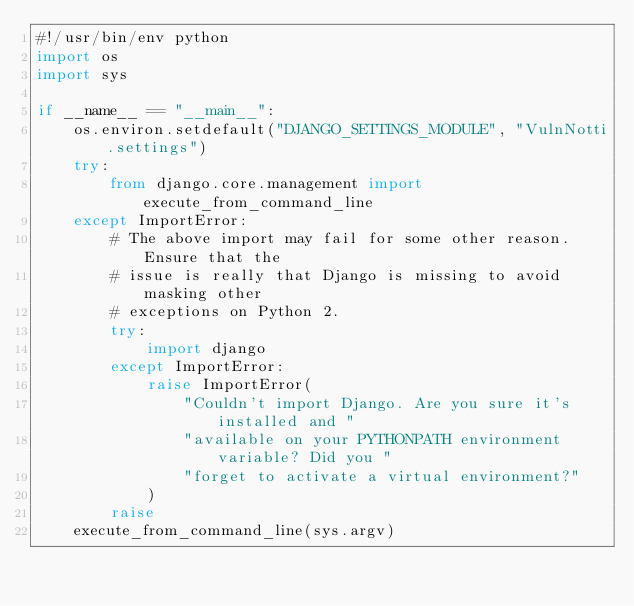<code> <loc_0><loc_0><loc_500><loc_500><_Python_>#!/usr/bin/env python
import os
import sys

if __name__ == "__main__":
    os.environ.setdefault("DJANGO_SETTINGS_MODULE", "VulnNotti.settings")
    try:
        from django.core.management import execute_from_command_line
    except ImportError:
        # The above import may fail for some other reason. Ensure that the
        # issue is really that Django is missing to avoid masking other
        # exceptions on Python 2.
        try:
            import django
        except ImportError:
            raise ImportError(
                "Couldn't import Django. Are you sure it's installed and "
                "available on your PYTHONPATH environment variable? Did you "
                "forget to activate a virtual environment?"
            )
        raise
    execute_from_command_line(sys.argv)
</code> 